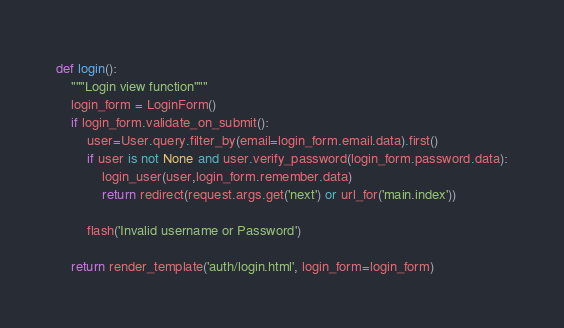Convert code to text. <code><loc_0><loc_0><loc_500><loc_500><_Python_>def login():
    """Login view function"""
    login_form = LoginForm()
    if login_form.validate_on_submit():
        user=User.query.filter_by(email=login_form.email.data).first()
        if user is not None and user.verify_password(login_form.password.data):
            login_user(user,login_form.remember.data)
            return redirect(request.args.get('next') or url_for('main.index'))

        flash('Invalid username or Password')

    return render_template('auth/login.html', login_form=login_form) </code> 